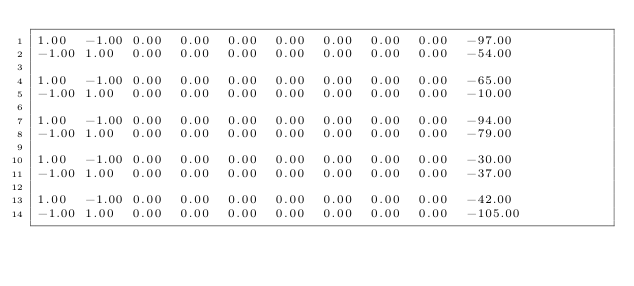Convert code to text. <code><loc_0><loc_0><loc_500><loc_500><_Matlab_>1.00	-1.00	0.00	0.00	0.00	0.00	0.00	0.00	0.00	-97.00
-1.00	1.00	0.00	0.00	0.00	0.00	0.00	0.00	0.00	-54.00

1.00	-1.00	0.00	0.00	0.00	0.00	0.00	0.00	0.00	-65.00
-1.00	1.00	0.00	0.00	0.00	0.00	0.00	0.00	0.00	-10.00

1.00	-1.00	0.00	0.00	0.00	0.00	0.00	0.00	0.00	-94.00
-1.00	1.00	0.00	0.00	0.00	0.00	0.00	0.00	0.00	-79.00

1.00	-1.00	0.00	0.00	0.00	0.00	0.00	0.00	0.00	-30.00
-1.00	1.00	0.00	0.00	0.00	0.00	0.00	0.00	0.00	-37.00

1.00	-1.00	0.00	0.00	0.00	0.00	0.00	0.00	0.00	-42.00
-1.00	1.00	0.00	0.00	0.00	0.00	0.00	0.00	0.00	-105.00
</code> 